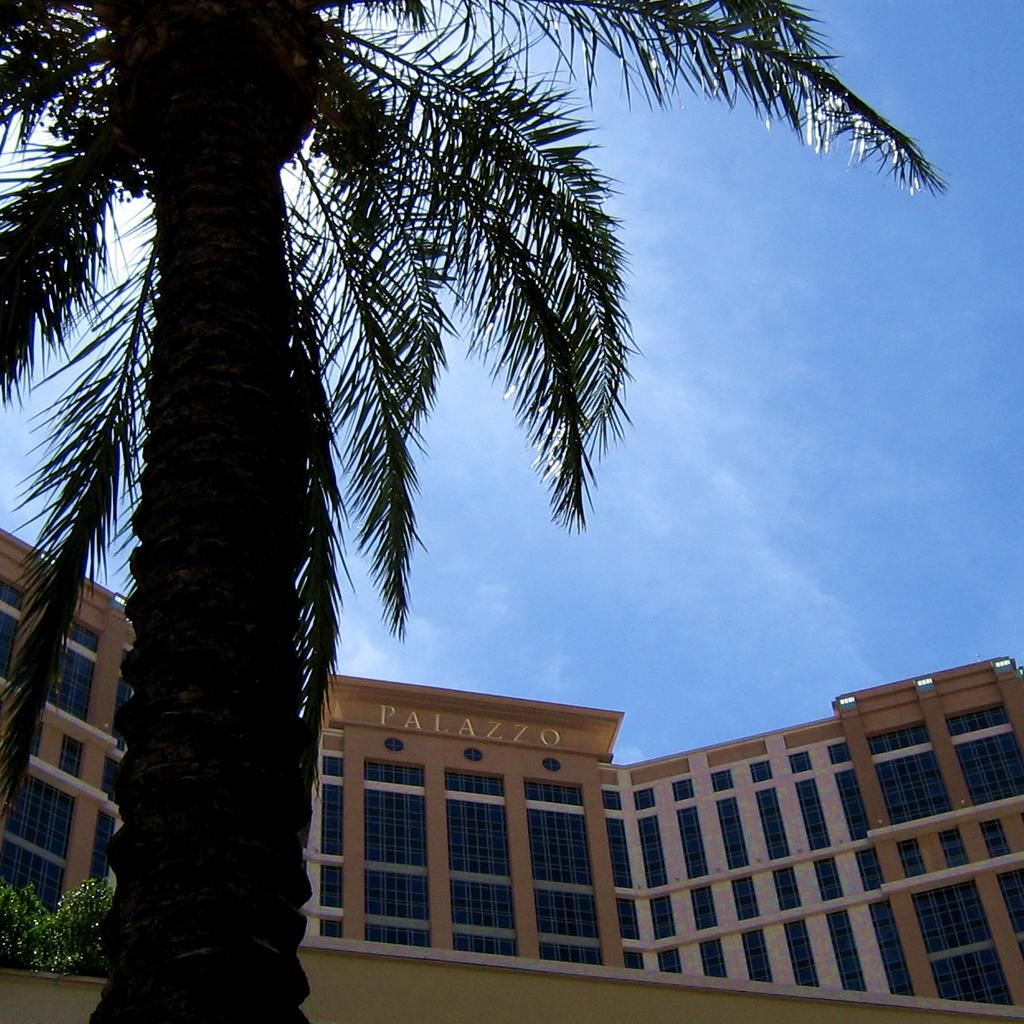What type of view is shown in the image? The image is an outside view. What can be seen on the left side of the image? There is a coconut tree and plants on the left side of the image. What is visible in the background of the image? There is a building in the background of the image. What is the color of the sky in the image? The sky is visible in the image, and it is blue in color. What type of stocking is hanging from the coconut tree in the image? There is no stocking hanging from the coconut tree in the image. Can you see a whip being used in the image? There is no whip visible in the image. 